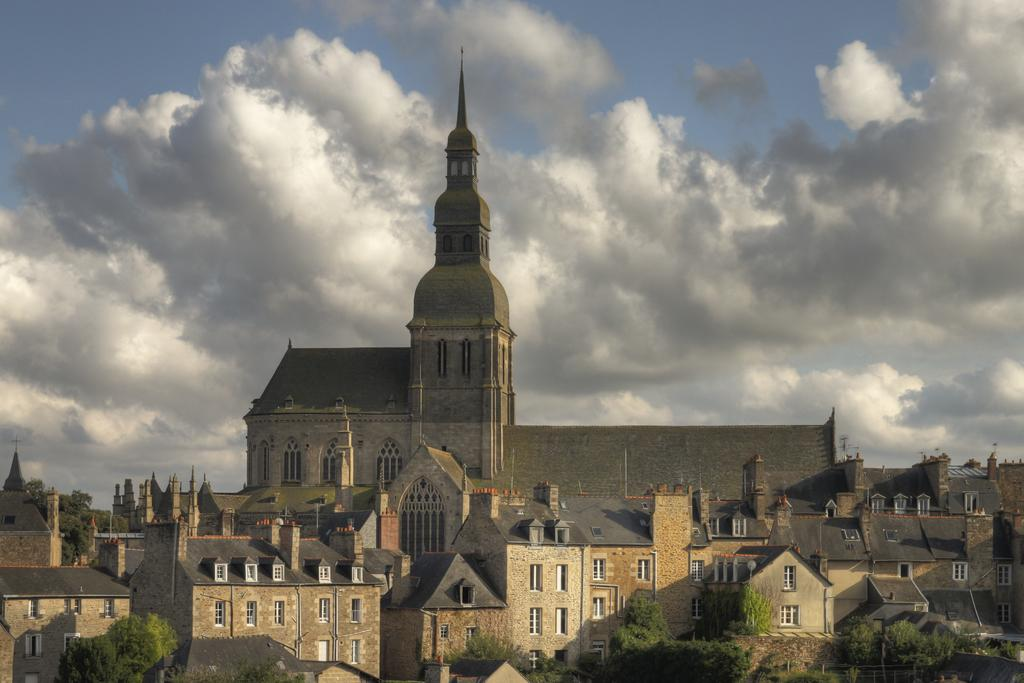What type of structures can be seen in the image? There are houses and buildings in the image. What other elements are present in the image besides structures? There are trees in the image. What can be seen in the background of the image? The sky is visible in the image. What is the weather like in the image? The image appears to have been taken on a sunny day. What type of wool is being used to support the knee in the image? There is no wool or knee present in the image. 